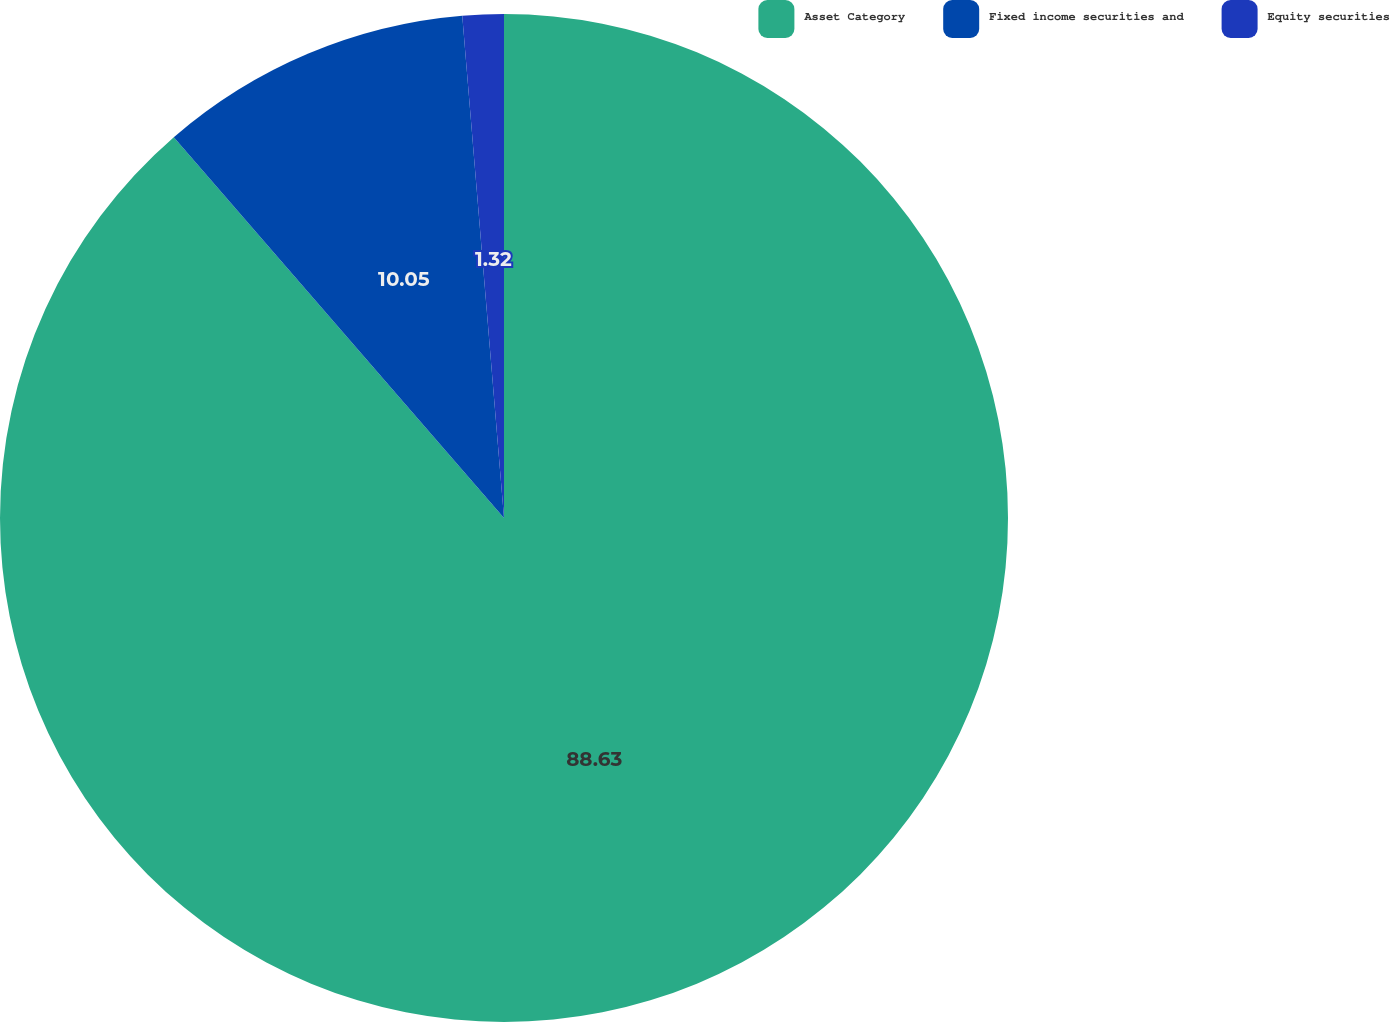Convert chart. <chart><loc_0><loc_0><loc_500><loc_500><pie_chart><fcel>Asset Category<fcel>Fixed income securities and<fcel>Equity securities<nl><fcel>88.63%<fcel>10.05%<fcel>1.32%<nl></chart> 